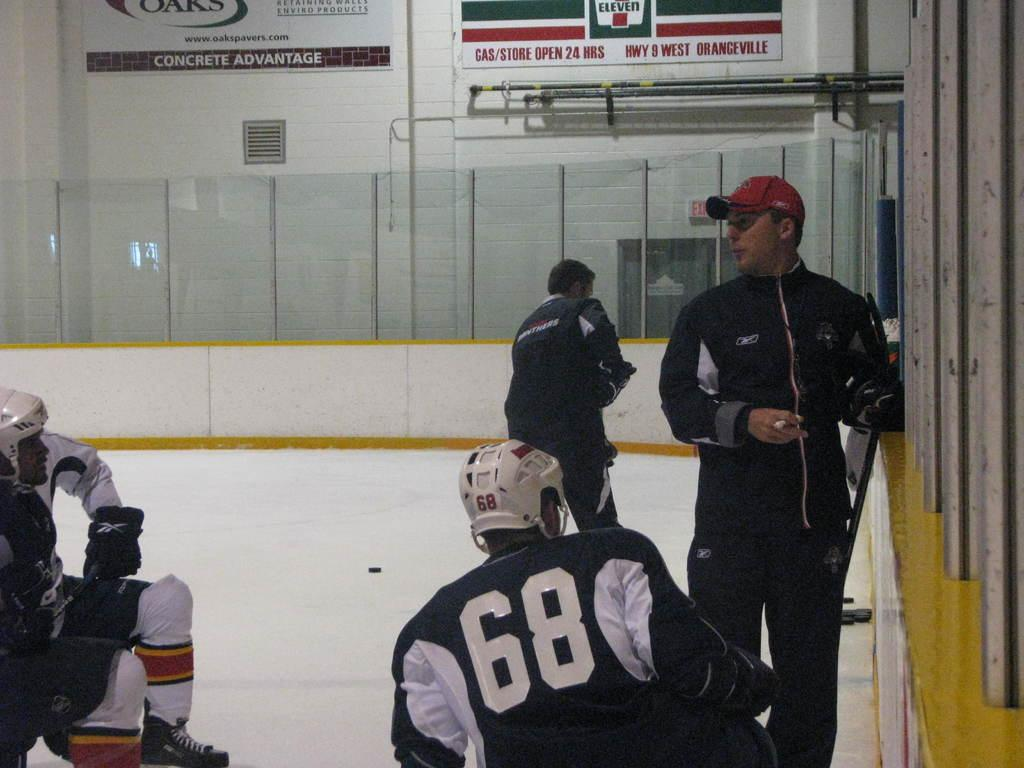<image>
Offer a succinct explanation of the picture presented. One of the sponsors of this hockey team is 7/11. 